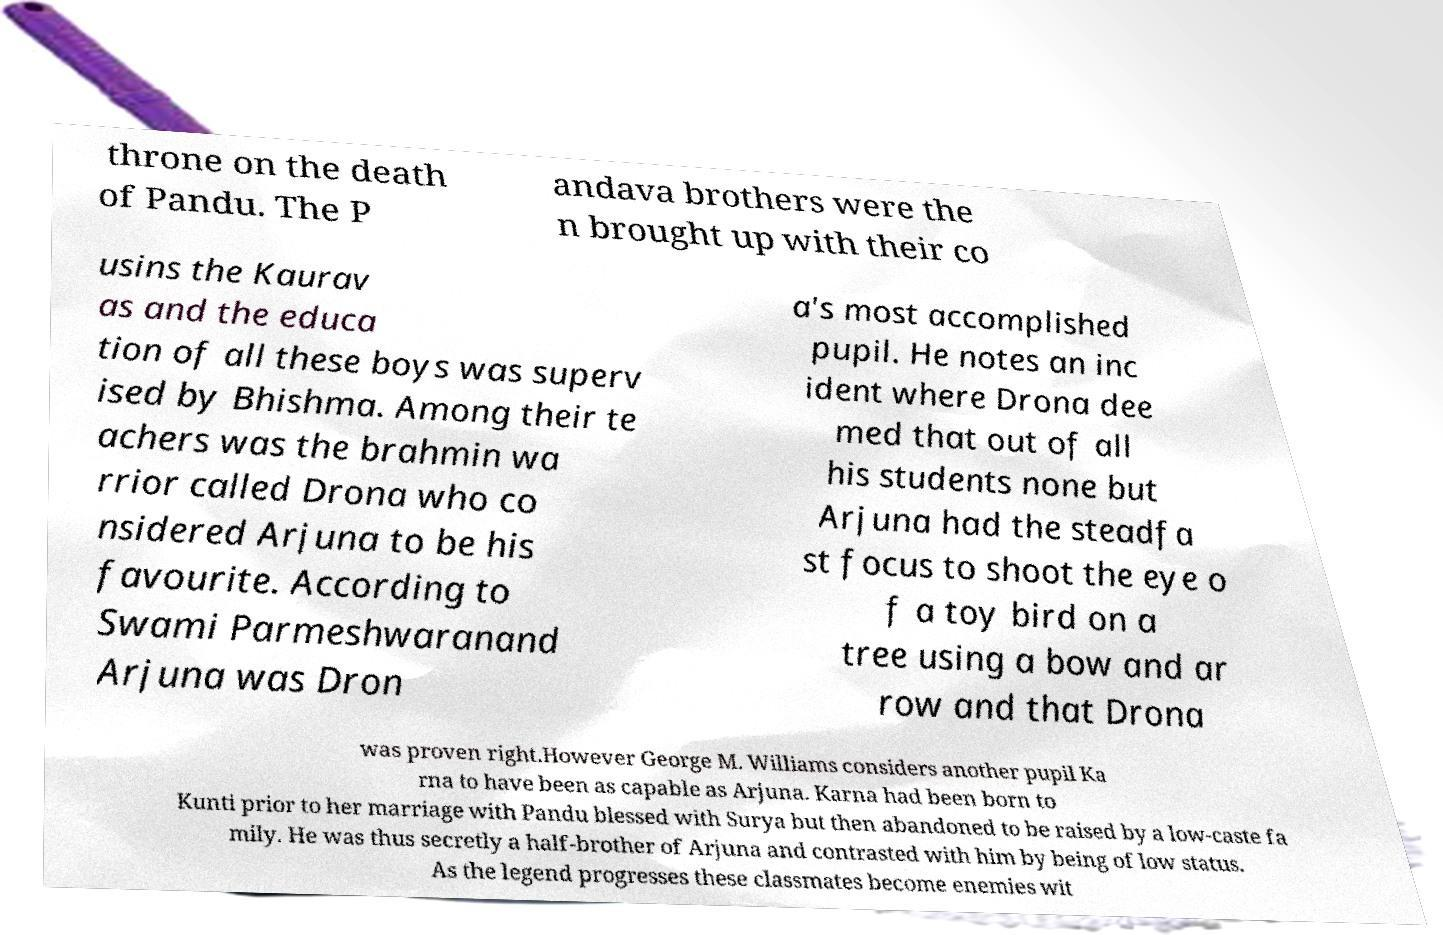Please identify and transcribe the text found in this image. throne on the death of Pandu. The P andava brothers were the n brought up with their co usins the Kaurav as and the educa tion of all these boys was superv ised by Bhishma. Among their te achers was the brahmin wa rrior called Drona who co nsidered Arjuna to be his favourite. According to Swami Parmeshwaranand Arjuna was Dron a's most accomplished pupil. He notes an inc ident where Drona dee med that out of all his students none but Arjuna had the steadfa st focus to shoot the eye o f a toy bird on a tree using a bow and ar row and that Drona was proven right.However George M. Williams considers another pupil Ka rna to have been as capable as Arjuna. Karna had been born to Kunti prior to her marriage with Pandu blessed with Surya but then abandoned to be raised by a low-caste fa mily. He was thus secretly a half-brother of Arjuna and contrasted with him by being of low status. As the legend progresses these classmates become enemies wit 